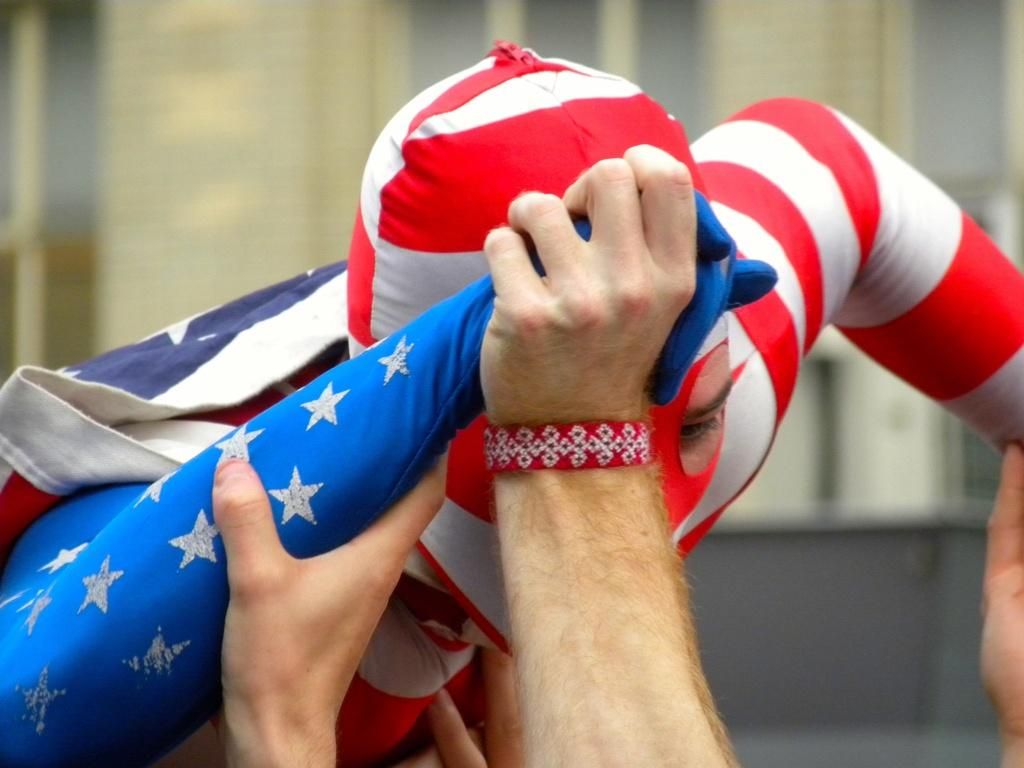Who or what is present in the image? There is a person in the image. What is the person wearing? The person is wearing a dress with red and blue colors. How is the person being supported or held in the image? The person is being held by human hands. What is the profit margin of the cup in the image? There is no cup present in the image, and therefore no profit margin can be determined. 